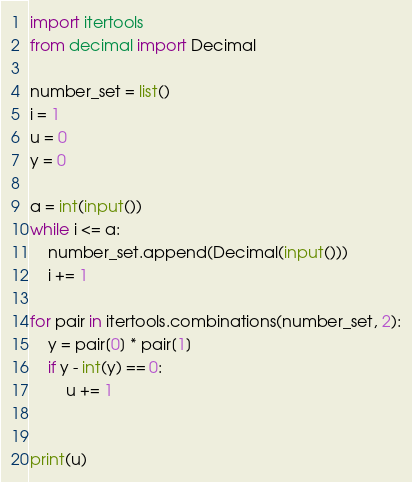Convert code to text. <code><loc_0><loc_0><loc_500><loc_500><_Python_>import itertools
from decimal import Decimal

number_set = list()
i = 1
u = 0
y = 0

a = int(input())
while i <= a:
    number_set.append(Decimal(input()))
    i += 1

for pair in itertools.combinations(number_set, 2):
    y = pair[0] * pair[1]
    if y - int(y) == 0:
        u += 1


print(u)</code> 